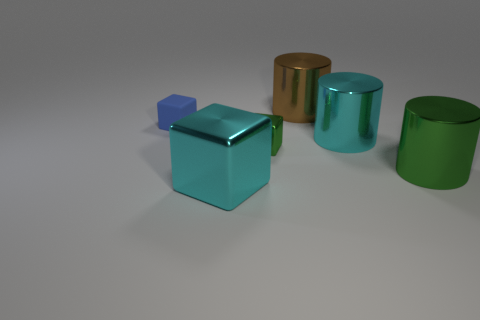Add 1 red blocks. How many objects exist? 7 Add 6 green blocks. How many green blocks exist? 7 Subtract 1 cyan cubes. How many objects are left? 5 Subtract all tiny yellow blocks. Subtract all green objects. How many objects are left? 4 Add 1 small green objects. How many small green objects are left? 2 